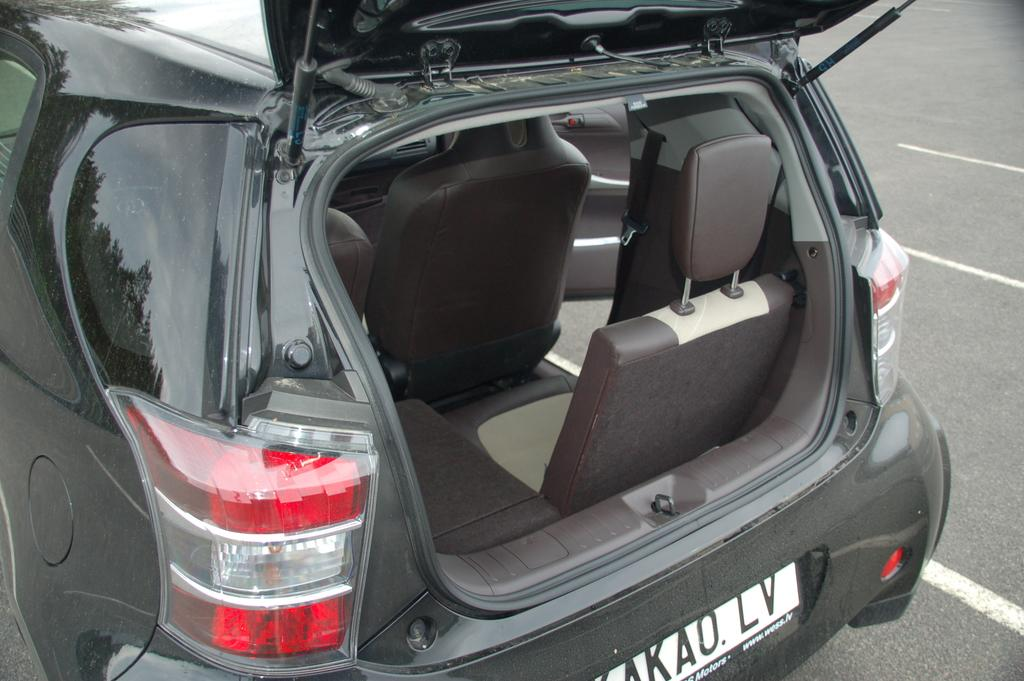Where was the image taken? The image is taken outdoors. What can be seen on the right side of the image? There is a road on the right side of the image. What is parked on the road in the image? A car is parked on the road on the left side of the image. What is the color of the car in the image? The car is black in color. What type of soda is being served at the playground in the image? There is no soda or playground present in the image; it features a road and a parked car. 